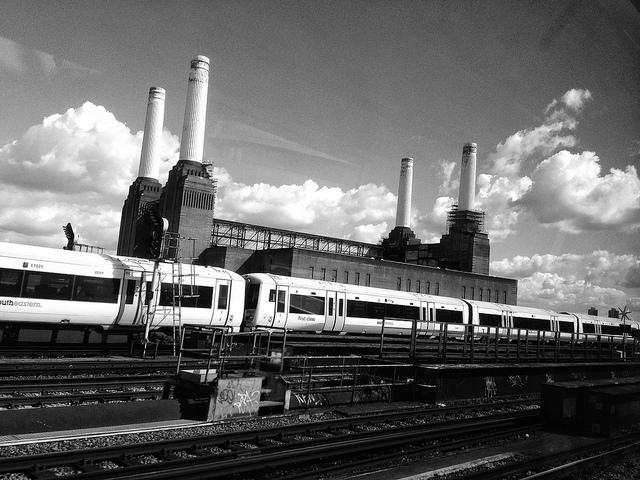Is the photo colored?
Answer briefly. No. Is there a flag on the train?
Short answer required. No. What year is the was this photo taken?
Quick response, please. 1980. How many smoke stacks are there?
Quick response, please. 4. 